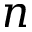<formula> <loc_0><loc_0><loc_500><loc_500>n</formula> 